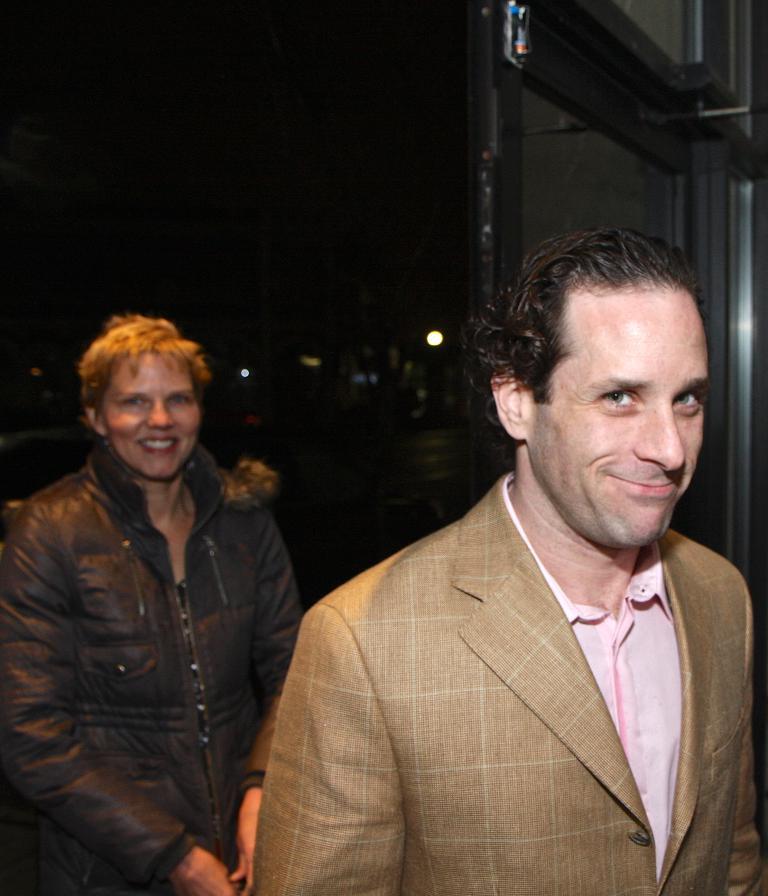In one or two sentences, can you explain what this image depicts? In this image there are two people standing and smiling. In the background there is a wall and we can see lights. 